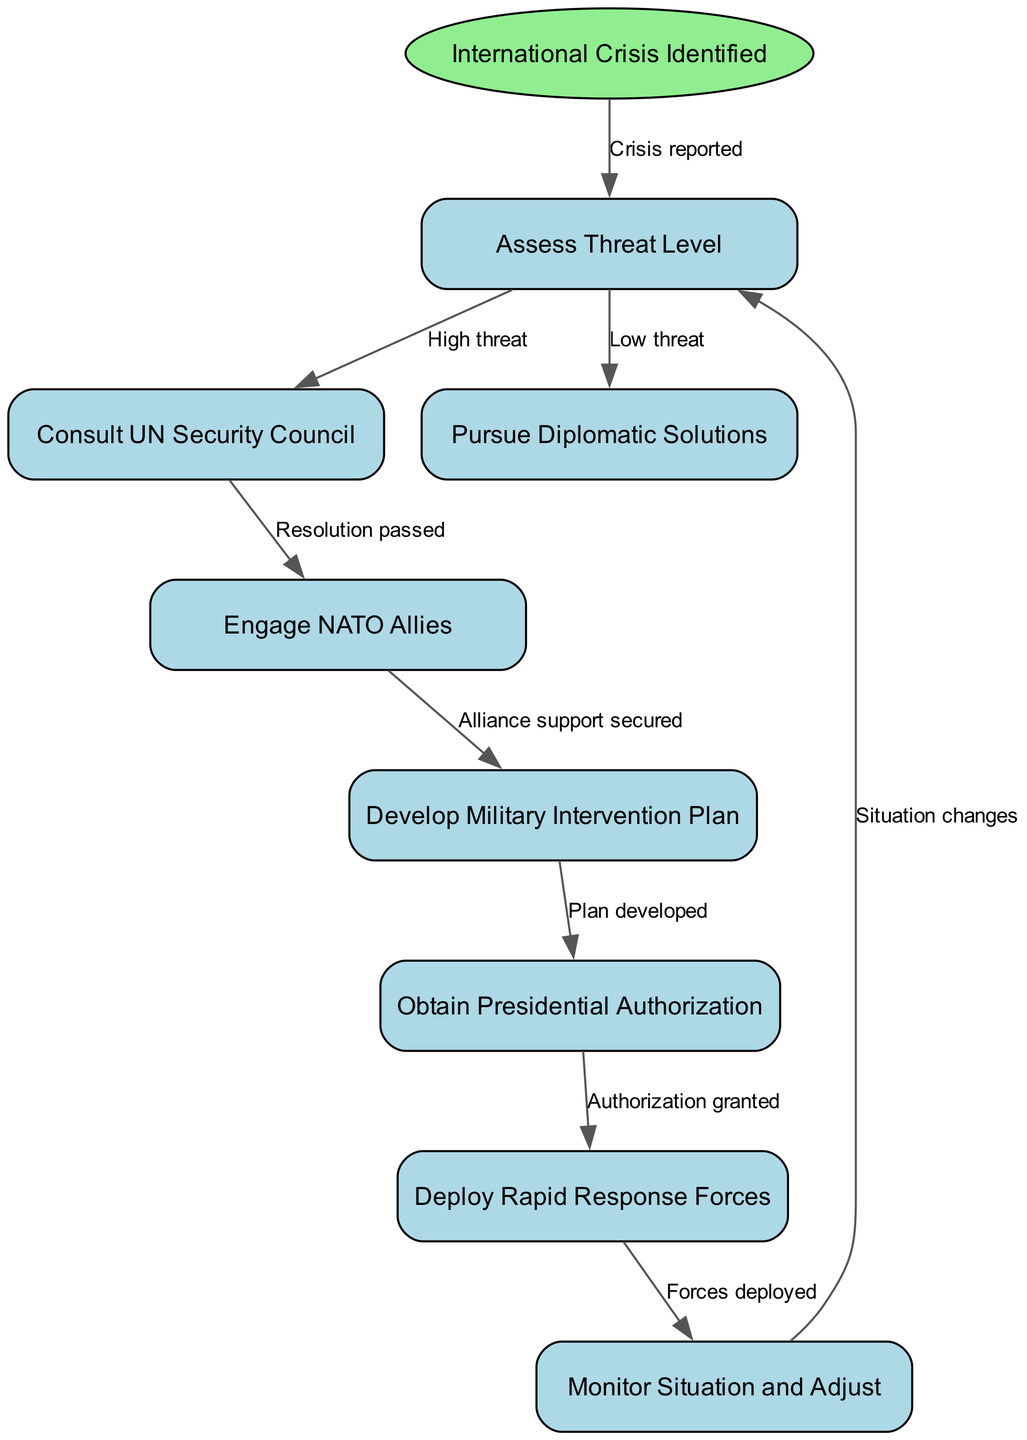What is the first step in the flowchart? The flowchart begins with the node labeled "International Crisis Identified," which is the starting point of the process. This step denotes the recognition of a global or internal issue requiring a response.
Answer: International Crisis Identified How many nodes are in the diagram? By counting the individual nodes listed in the flowchart, there are eight nodes total: the start node and seven subsequent nodes.
Answer: 8 What is the next step after "Assess Threat Level" if the threat is high? If the threat is deemed high after the "Assess Threat Level" step, the process leads to the "Consult UN Security Council" node, indicating the importance of international collaboration at this stage.
Answer: Consult UN Security Council What is the relationship between "Consult UN Security Council" and "Engage NATO Allies"? The "Consult UN Security Council" node connects to the "Engage NATO Allies" node, illustrating that the next action depends on a resolution being passed in the UN, thereby highlighting the collaboration needed among different international organizations.
Answer: Resolution passed How does "Deploy Rapid Response Forces" connect to the flowchart process? The "Deploy Rapid Response Forces" step follows the "Obtain Presidential Authorization," indicating that military deployment occurs only after formal approval, thus emphasizing the importance of legal and political backing in military operations.
Answer: Authorization granted What happens when the situation changes after deployment? After deploying forces, if the situation changes, the flow goes back to the "Assess Threat Level" node, demonstrating the iterative nature of monitoring and adapting military intervention to evolving circumstances.
Answer: Situation changes Which node represents the development of a military plan? The node labeled "Develop Military Intervention Plan" signifies the specific step where strategic plans are crafted to address the identified threat, an essential component before any military action takes place.
Answer: Develop Military Intervention Plan What triggers the "Monitor Situation and Adjust" phase? The trigger for the "Monitor Situation and Adjust" phase is the completion of the "Deploy Rapid Response Forces," marking a transition into an ongoing evaluation phase to ensure the effectiveness of the interventions.
Answer: Forces deployed 